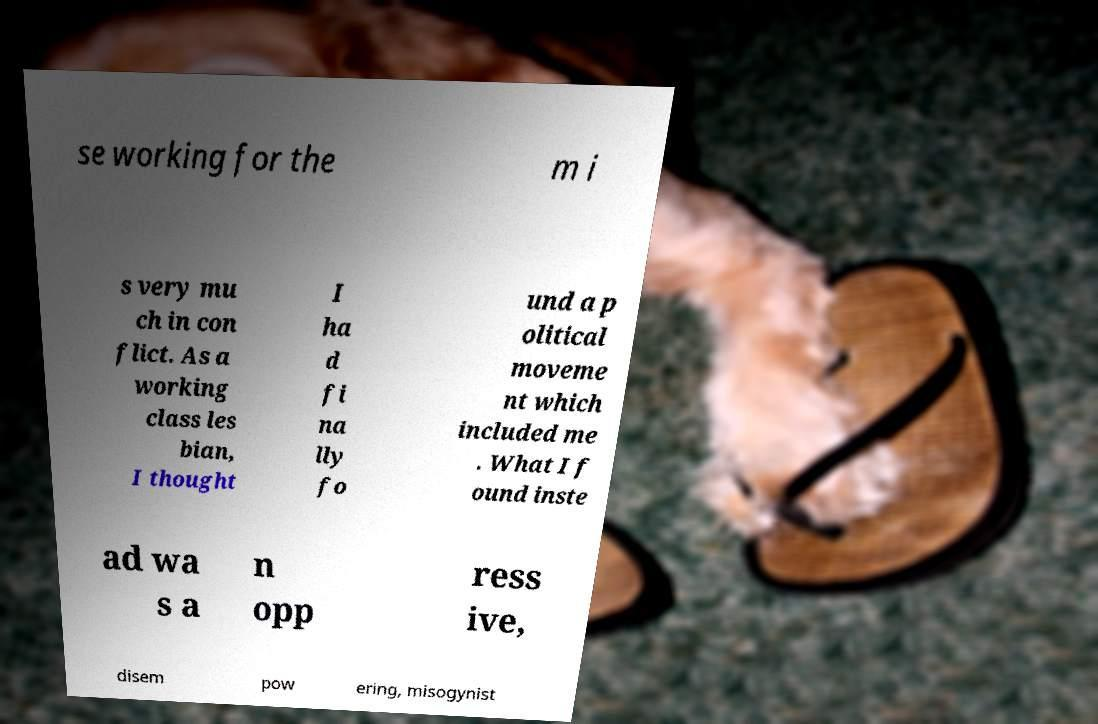Please read and relay the text visible in this image. What does it say? se working for the m i s very mu ch in con flict. As a working class les bian, I thought I ha d fi na lly fo und a p olitical moveme nt which included me . What I f ound inste ad wa s a n opp ress ive, disem pow ering, misogynist 